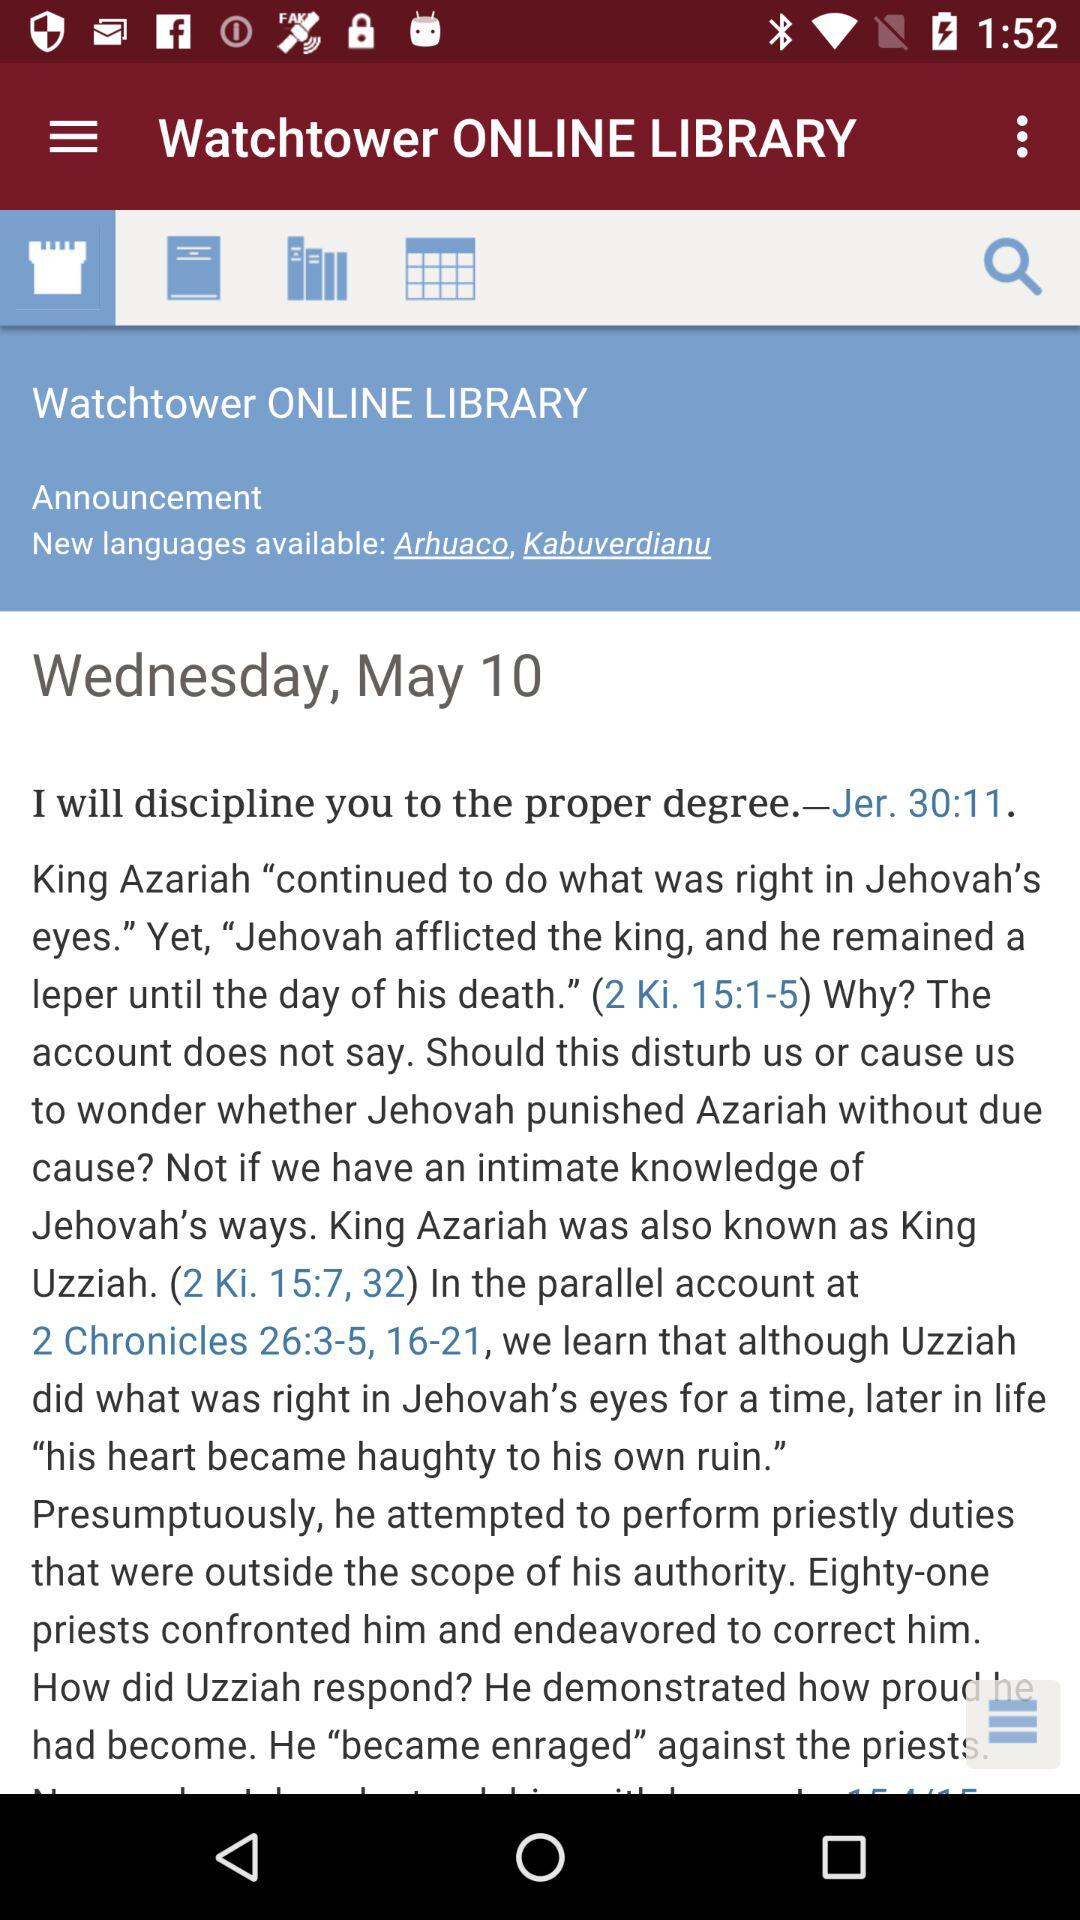How many languages are available in the new announcement?
Answer the question using a single word or phrase. 2 